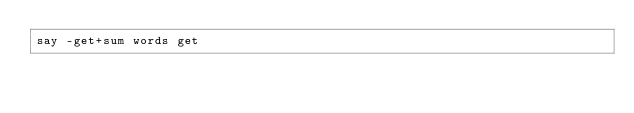<code> <loc_0><loc_0><loc_500><loc_500><_Perl_>say -get+sum words get</code> 